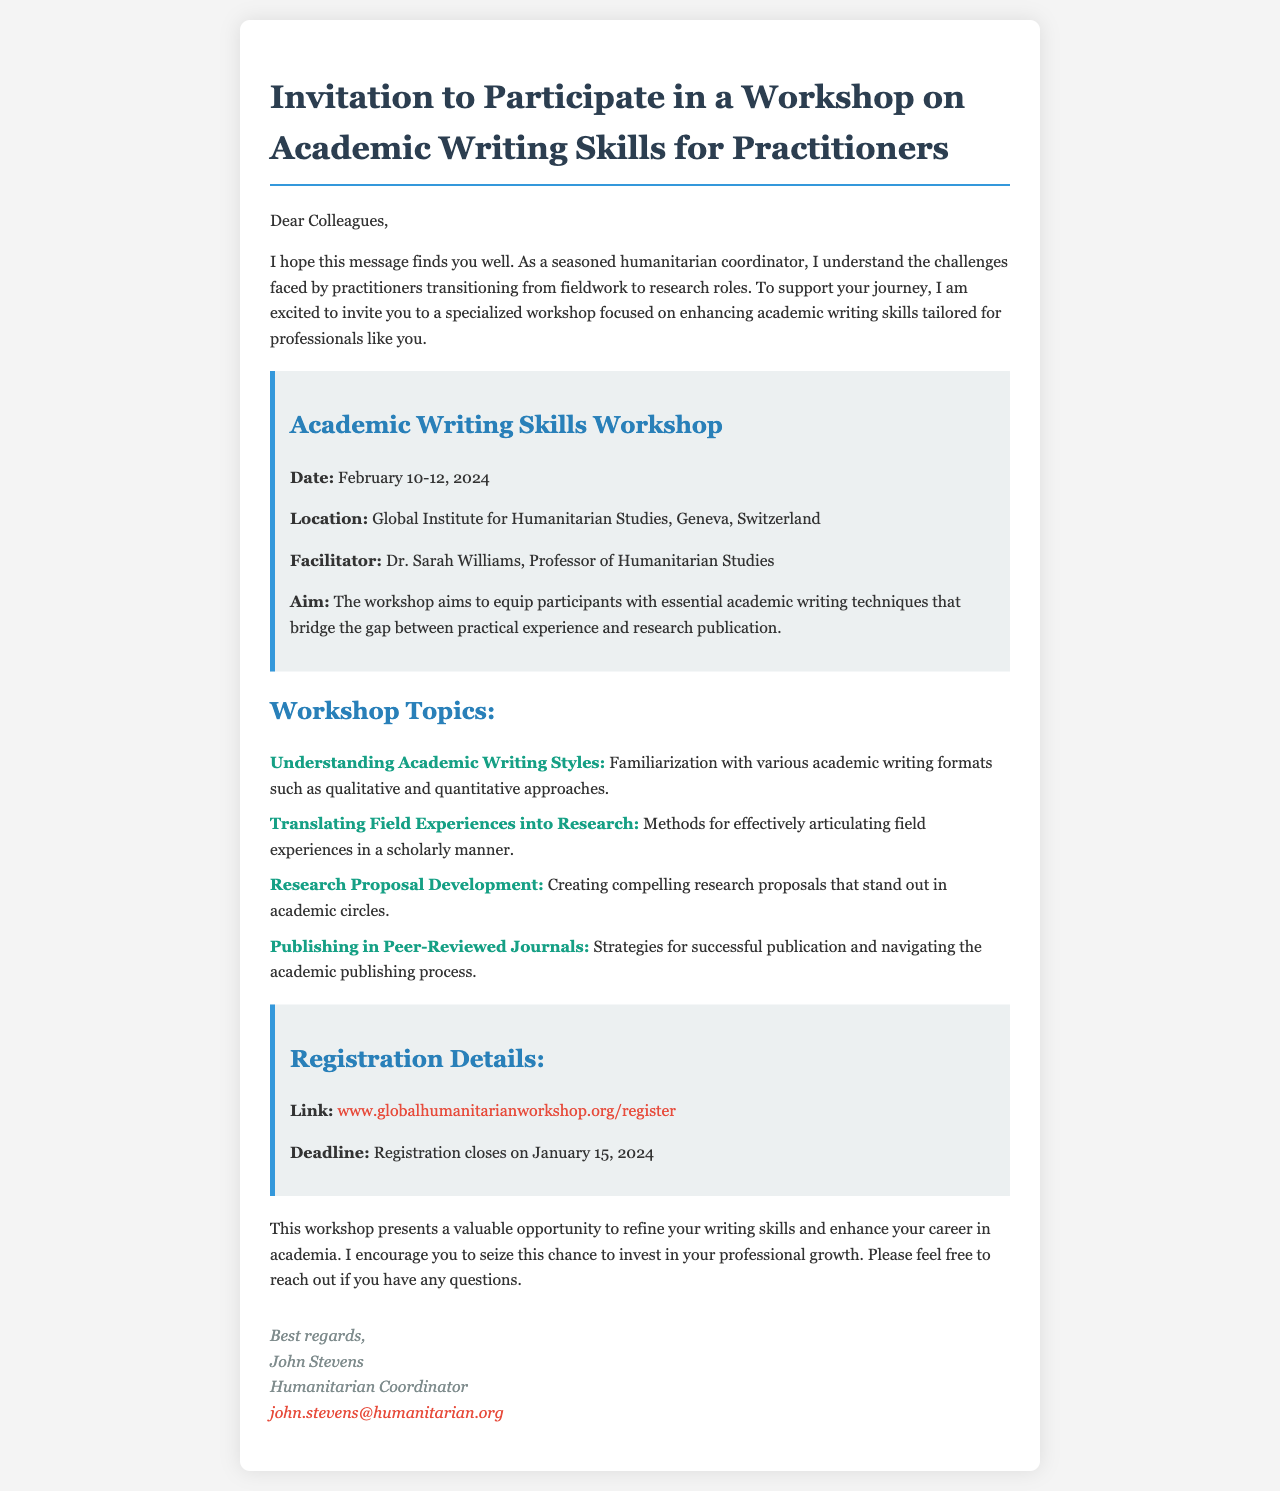What are the dates of the workshop? The dates are clearly stated in the workshop details section of the email.
Answer: February 10-12, 2024 Where is the workshop location? The location is provided under the workshop details in the document.
Answer: Geneva, Switzerland Who is the facilitator of the workshop? The facilitator's name is mentioned in the details section of the email.
Answer: Dr. Sarah Williams What is one of the workshop topics? The topics list outlines various subjects related to academic writing skills.
Answer: Understanding Academic Writing Styles What is the registration deadline? The deadline for registration is included in the registration details section of the email.
Answer: January 15, 2024 What is the main aim of the workshop? The aim is summarized in the aim section within the details part of the document.
Answer: Equip participants with essential academic writing techniques What is the registration link? The registration link is provided in the registration details section of the email.
Answer: www.globalhumanitarianworkshop.org/register Who is sending the invitation? The signature at the end of the email indicates the sender's name and title.
Answer: John Stevens What type of workshop is being discussed? The subject of the email clearly indicates the type of workshop being offered.
Answer: Academic Writing Skills Workshop 